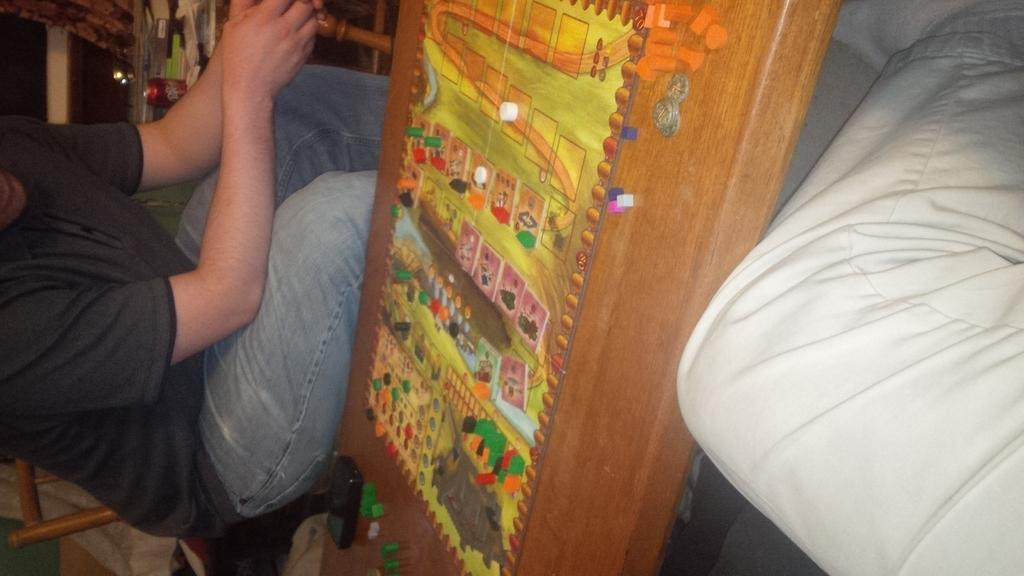What are the persons in the image doing? The persons in the image are sitting. What type of object made of wood can be seen in the image? There is a wooden object in the image. What type of container is present in the image? There is a can in the image. What type of bat is flying around in the image? There is no bat present in the image. What type of doctor is attending to the persons in the image? There is no doctor present in the image. 